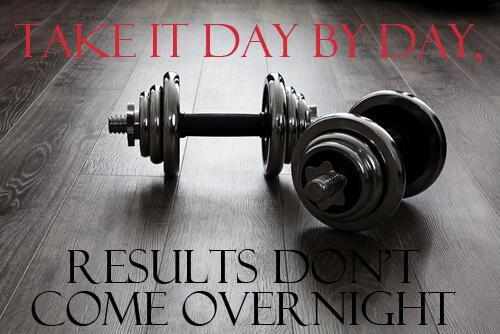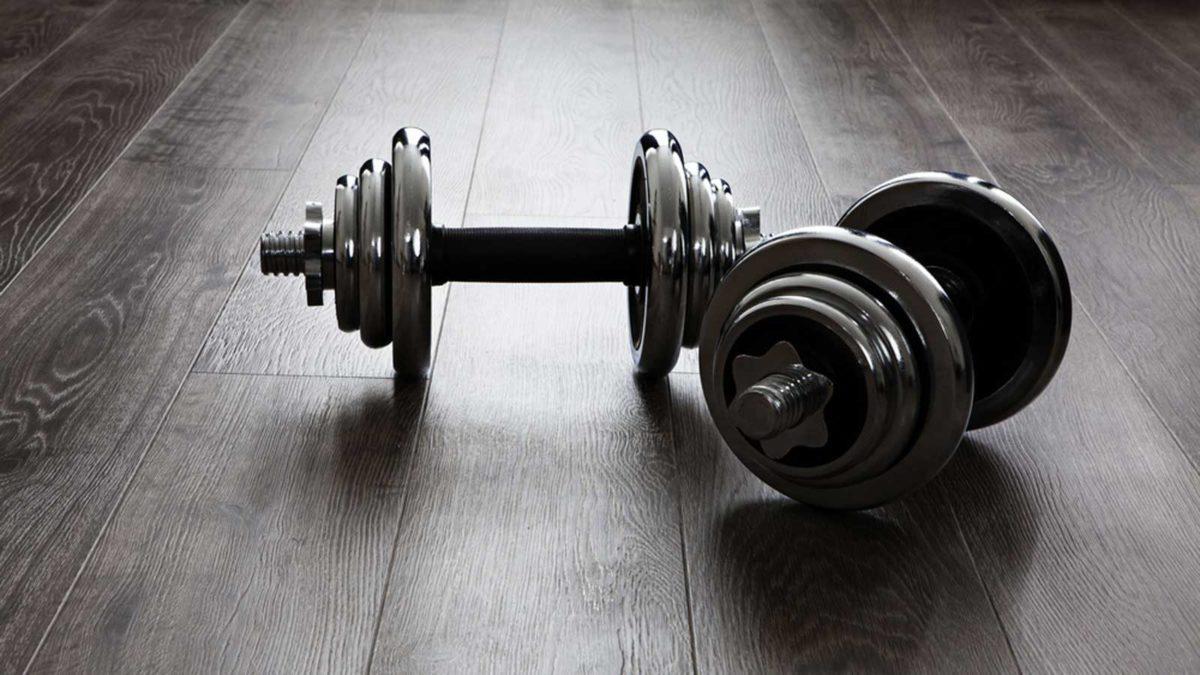The first image is the image on the left, the second image is the image on the right. Examine the images to the left and right. Is the description "The rack in the image on the right holds more than a dozen weights." accurate? Answer yes or no. No. The first image is the image on the left, the second image is the image on the right. Given the left and right images, does the statement "In one of the images there is a large rack full of various sized barbells." hold true? Answer yes or no. No. 